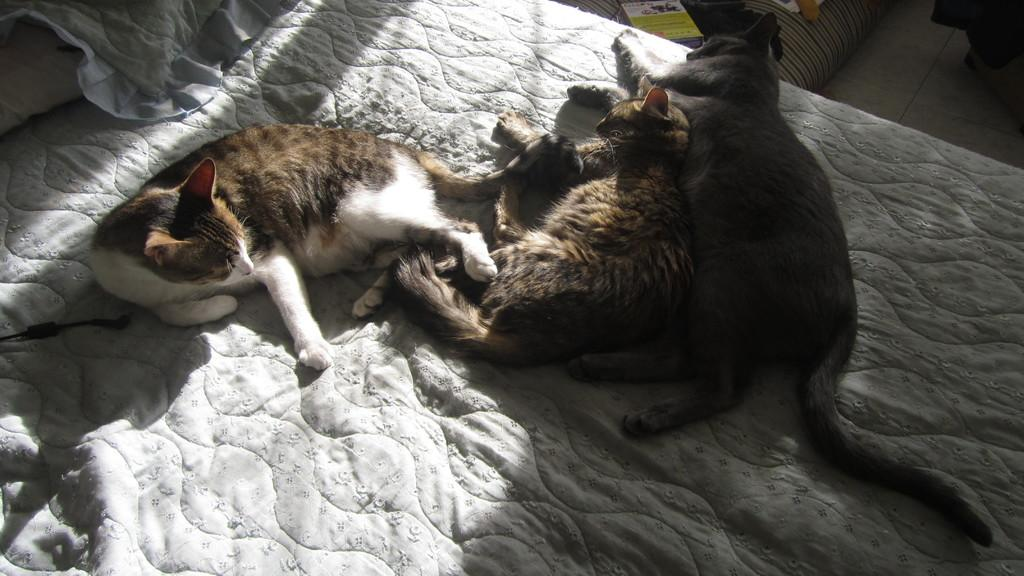How many cats are in the image? There are three cats in the image. What are the cats doing in the image? The cats are sleeping. Where are the cats located in the image? The cats are on a bed. What type of skate is the cat using to perform tricks in the image? There is no skate present in the image, and the cats are sleeping, not performing tricks. 